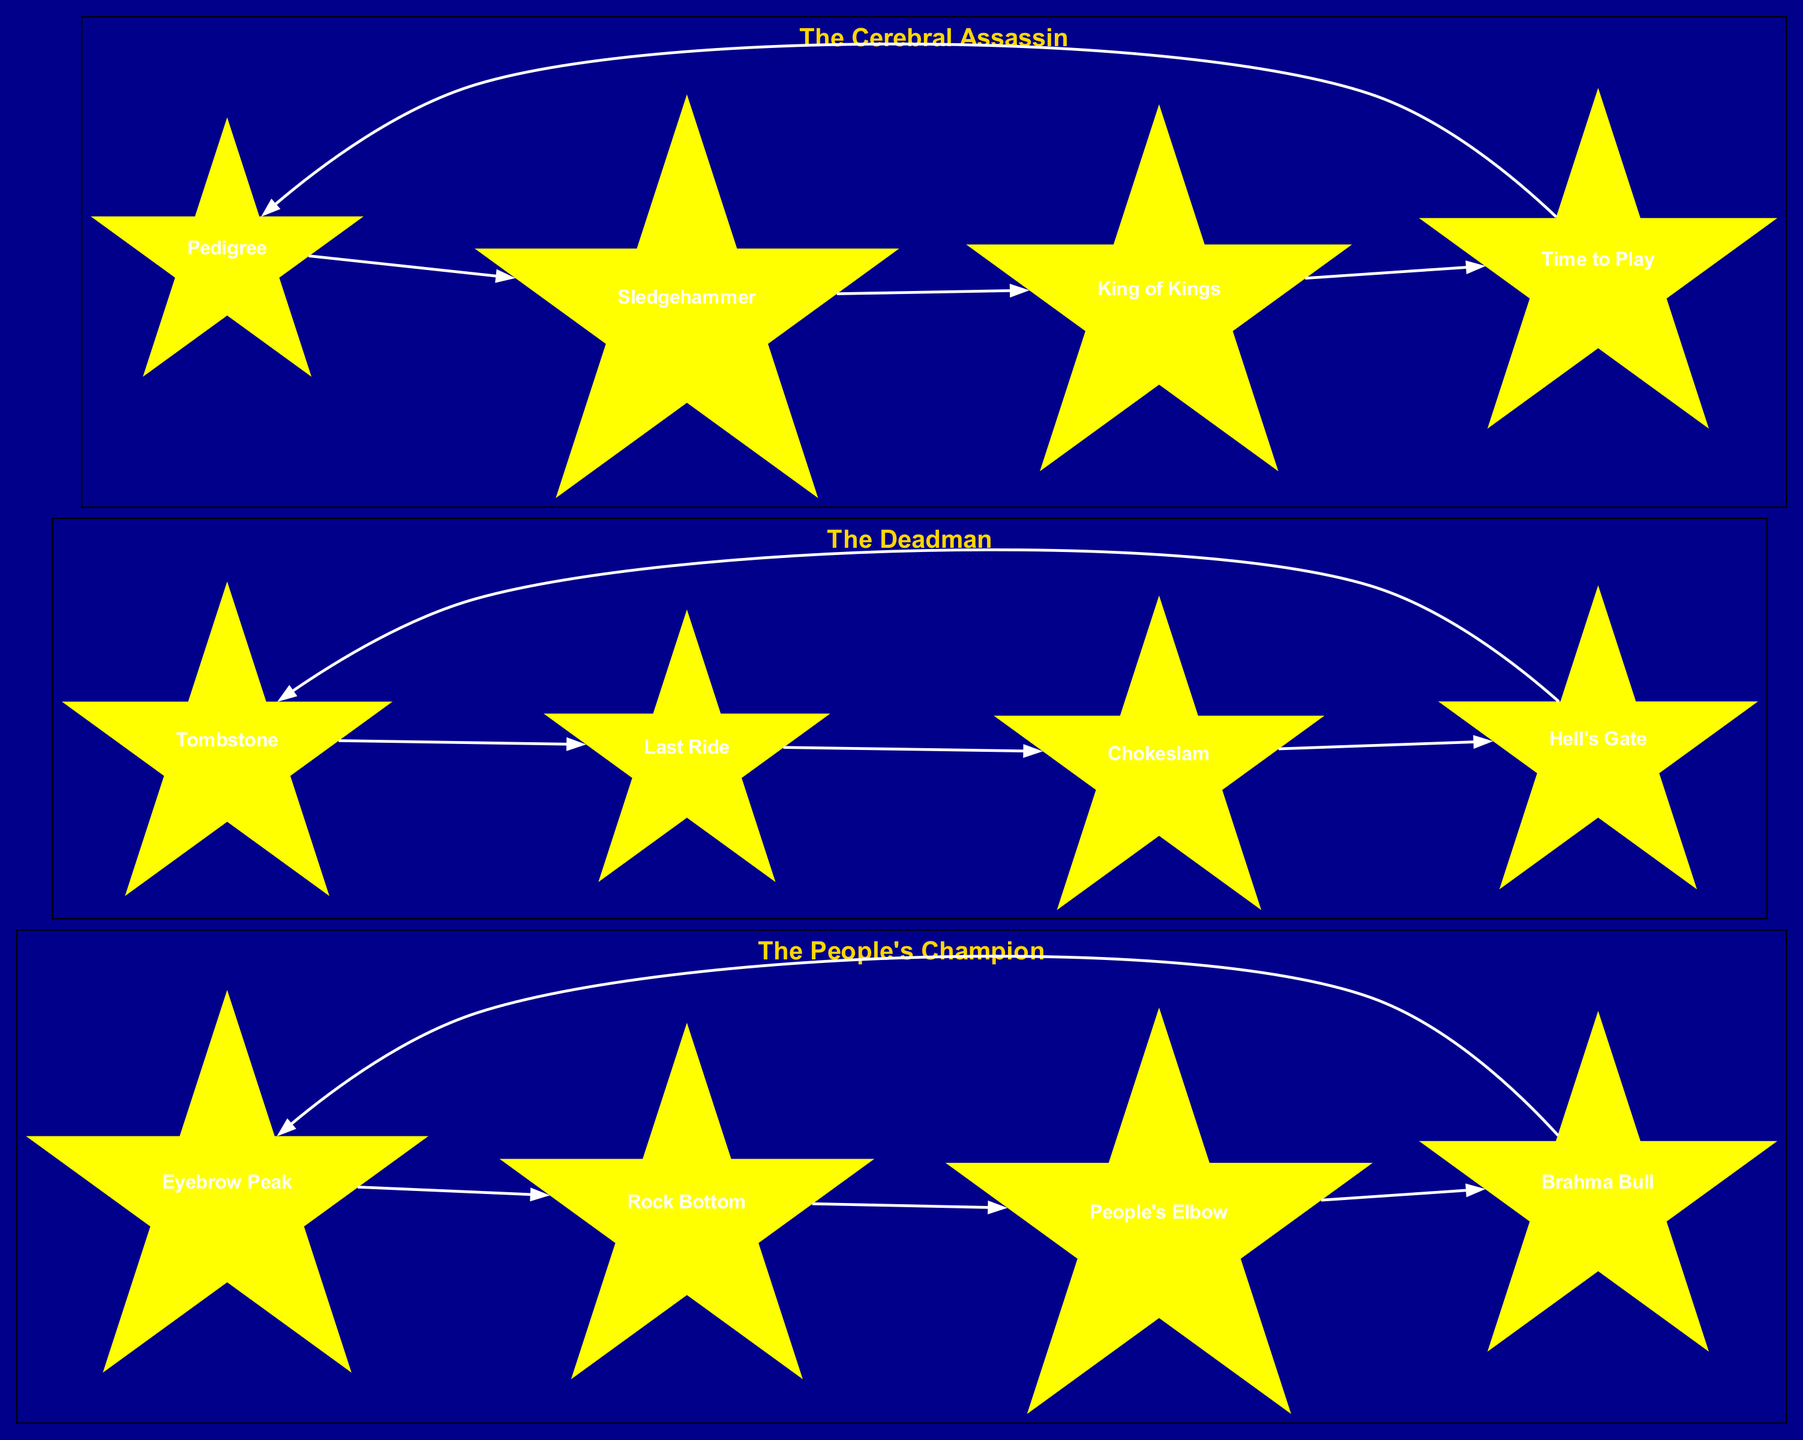What is the name of the constellation inspired by The Rock? The diagram labels the constellation inspired by The Rock as "The People's Champion". You can find it at the top of its cluster.
Answer: The People's Champion How many stars are in the constellation of The Deadman? In the cluster representing The Deadman, there are four stars listed: Tombstone, Last Ride, Chokeslam, and Hell's Gate. Counting these gives a total of four stars.
Answer: 4 Which star connects Tombstone to Last Ride? Referring to the connections in The Deadman constellation, the edge directly links Tombstone (which is star 1) to Last Ride (which is star 2). This connection is explicitly shown in the diagram.
Answer: Last Ride What are the names of the stars in The Cerebral Assassin constellation? The stars in The Cerebral Assassin constellation are listed as Pedigree, Sledgehammer, King of Kings, and Time to Play. These names can be directly found within the cluster names.
Answer: Pedigree, Sledgehammer, King of Kings, Time to Play Which stars form a closed connection in The People's Champion constellation? The connections among the stars Eyebrow Peak, Rock Bottom, People's Elbow, and Brahma Bull in The People's Champion constellation create a closed loop. Each star connects to the next, returning to the starting point, which is Eyebrow Peak.
Answer: Eyebrow Peak, Rock Bottom, People's Elbow, Brahma Bull How many connections does The Cerebral Assassin have? The diagram indicates that there are four connections in The Cerebral Assassin constellation: Pedigree to Sledgehammer, Sledgehammer to King of Kings, King of Kings to Time to Play, and Time to Play back to Pedigree. Thus, there are a total of four connections.
Answer: 4 What is the primary inspiration for the constellation named The Deadman? The label in the diagram indicates that The Deadman constellation is inspired by The Undertaker. This information is typically found at the top of the cluster for easy reference.
Answer: The Undertaker Which connection in The People's Champion includes the star named Rock Bottom? In The People's Champion constellation, the connection moves from Rock Bottom (which is identified as star 2) to People's Elbow (which is identified as star 3). This edge is an explicit part of the connection list.
Answer: People's Elbow 